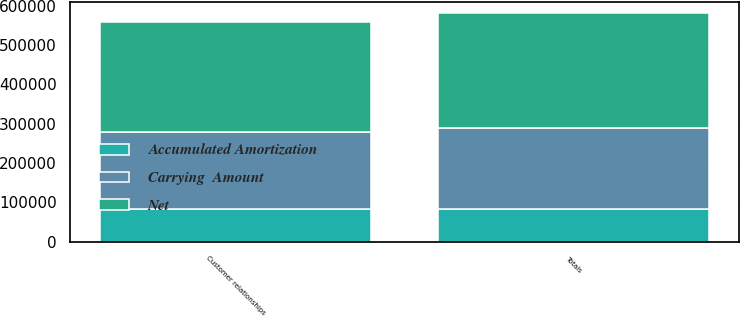Convert chart to OTSL. <chart><loc_0><loc_0><loc_500><loc_500><stacked_bar_chart><ecel><fcel>Customer relationships<fcel>Totals<nl><fcel>Net<fcel>279273<fcel>290107<nl><fcel>Accumulated Amortization<fcel>82945<fcel>82964<nl><fcel>Carrying  Amount<fcel>196328<fcel>207143<nl></chart> 